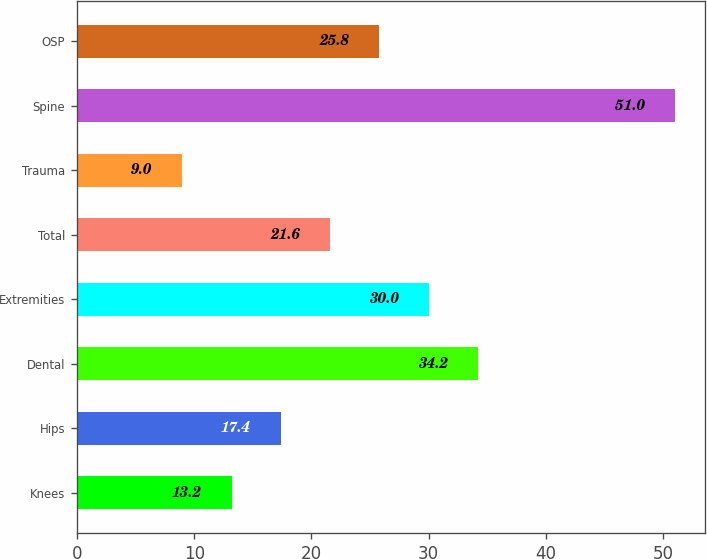Convert chart. <chart><loc_0><loc_0><loc_500><loc_500><bar_chart><fcel>Knees<fcel>Hips<fcel>Dental<fcel>Extremities<fcel>Total<fcel>Trauma<fcel>Spine<fcel>OSP<nl><fcel>13.2<fcel>17.4<fcel>34.2<fcel>30<fcel>21.6<fcel>9<fcel>51<fcel>25.8<nl></chart> 